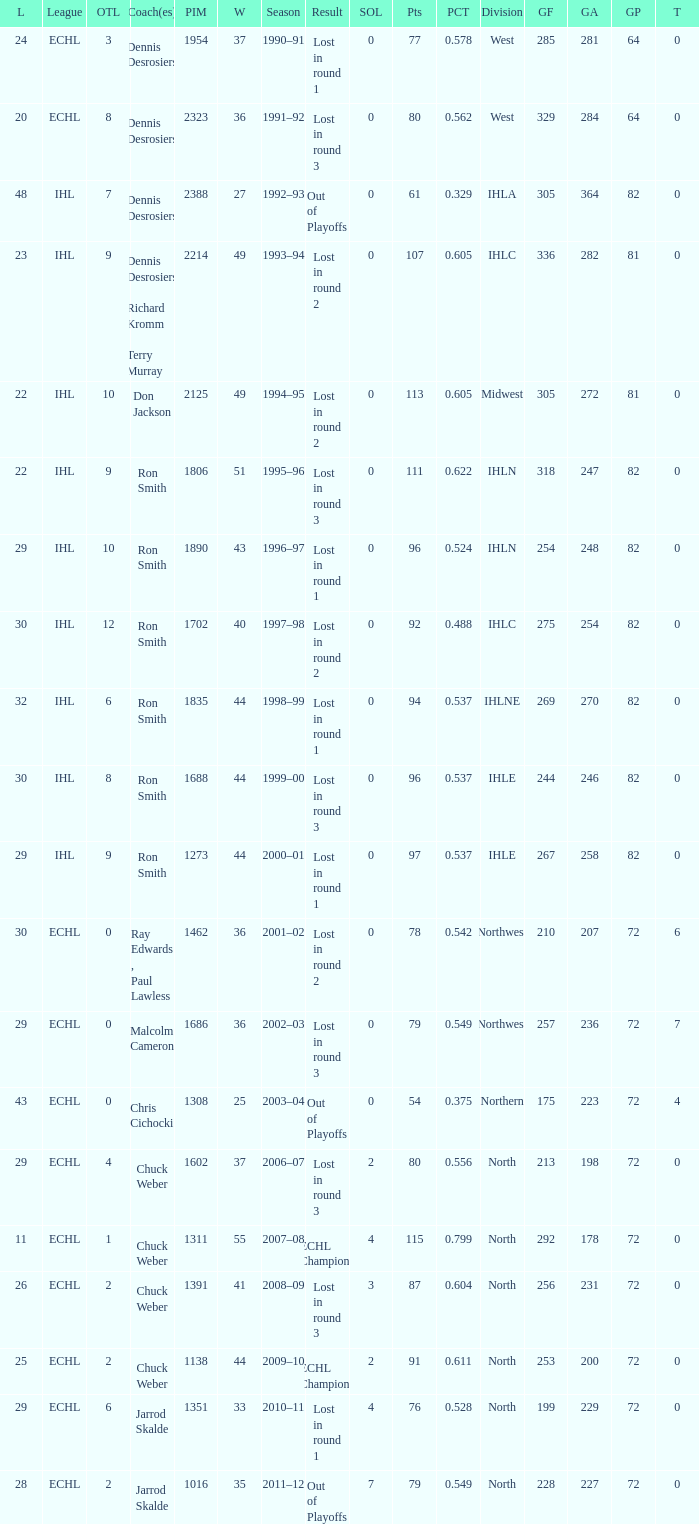Parse the table in full. {'header': ['L', 'League', 'OTL', 'Coach(es)', 'PIM', 'W', 'Season', 'Result', 'SOL', 'Pts', 'PCT', 'Division', 'GF', 'GA', 'GP', 'T'], 'rows': [['24', 'ECHL', '3', 'Dennis Desrosiers', '1954', '37', '1990–91', 'Lost in round 1', '0', '77', '0.578', 'West', '285', '281', '64', '0'], ['20', 'ECHL', '8', 'Dennis Desrosiers', '2323', '36', '1991–92', 'Lost in round 3', '0', '80', '0.562', 'West', '329', '284', '64', '0'], ['48', 'IHL', '7', 'Dennis Desrosiers', '2388', '27', '1992–93', 'Out of Playoffs', '0', '61', '0.329', 'IHLA', '305', '364', '82', '0'], ['23', 'IHL', '9', 'Dennis Desrosiers , Richard Kromm , Terry Murray', '2214', '49', '1993–94', 'Lost in round 2', '0', '107', '0.605', 'IHLC', '336', '282', '81', '0'], ['22', 'IHL', '10', 'Don Jackson', '2125', '49', '1994–95', 'Lost in round 2', '0', '113', '0.605', 'Midwest', '305', '272', '81', '0'], ['22', 'IHL', '9', 'Ron Smith', '1806', '51', '1995–96', 'Lost in round 3', '0', '111', '0.622', 'IHLN', '318', '247', '82', '0'], ['29', 'IHL', '10', 'Ron Smith', '1890', '43', '1996–97', 'Lost in round 1', '0', '96', '0.524', 'IHLN', '254', '248', '82', '0'], ['30', 'IHL', '12', 'Ron Smith', '1702', '40', '1997–98', 'Lost in round 2', '0', '92', '0.488', 'IHLC', '275', '254', '82', '0'], ['32', 'IHL', '6', 'Ron Smith', '1835', '44', '1998–99', 'Lost in round 1', '0', '94', '0.537', 'IHLNE', '269', '270', '82', '0'], ['30', 'IHL', '8', 'Ron Smith', '1688', '44', '1999–00', 'Lost in round 3', '0', '96', '0.537', 'IHLE', '244', '246', '82', '0'], ['29', 'IHL', '9', 'Ron Smith', '1273', '44', '2000–01', 'Lost in round 1', '0', '97', '0.537', 'IHLE', '267', '258', '82', '0'], ['30', 'ECHL', '0', 'Ray Edwards , Paul Lawless', '1462', '36', '2001–02', 'Lost in round 2', '0', '78', '0.542', 'Northwest', '210', '207', '72', '6'], ['29', 'ECHL', '0', 'Malcolm Cameron', '1686', '36', '2002–03', 'Lost in round 3', '0', '79', '0.549', 'Northwest', '257', '236', '72', '7'], ['43', 'ECHL', '0', 'Chris Cichocki', '1308', '25', '2003–04', 'Out of Playoffs', '0', '54', '0.375', 'Northern', '175', '223', '72', '4'], ['29', 'ECHL', '4', 'Chuck Weber', '1602', '37', '2006–07', 'Lost in round 3', '2', '80', '0.556', 'North', '213', '198', '72', '0'], ['11', 'ECHL', '1', 'Chuck Weber', '1311', '55', '2007–08', 'ECHL Champions', '4', '115', '0.799', 'North', '292', '178', '72', '0'], ['26', 'ECHL', '2', 'Chuck Weber', '1391', '41', '2008–09', 'Lost in round 3', '3', '87', '0.604', 'North', '256', '231', '72', '0'], ['25', 'ECHL', '2', 'Chuck Weber', '1138', '44', '2009–10', 'ECHL Champions', '2', '91', '0.611', 'North', '253', '200', '72', '0'], ['29', 'ECHL', '6', 'Jarrod Skalde', '1351', '33', '2010–11', 'Lost in round 1', '4', '76', '0.528', 'North', '199', '229', '72', '0'], ['28', 'ECHL', '2', 'Jarrod Skalde', '1016', '35', '2011–12', 'Out of Playoffs', '7', '79', '0.549', 'North', '228', '227', '72', '0']]} What was the highest SOL where the team lost in round 3? 3.0. 